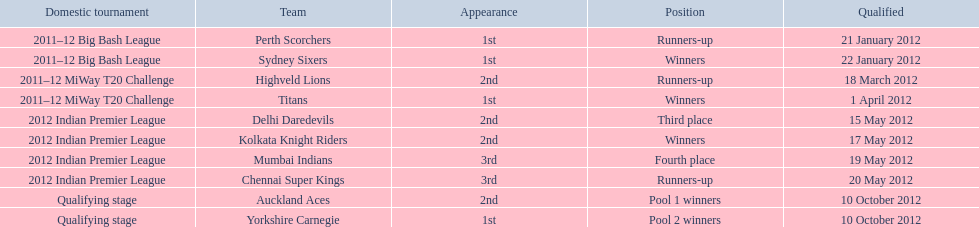The auckland aces and yorkshire carnegie qualified on what date? 10 October 2012. 